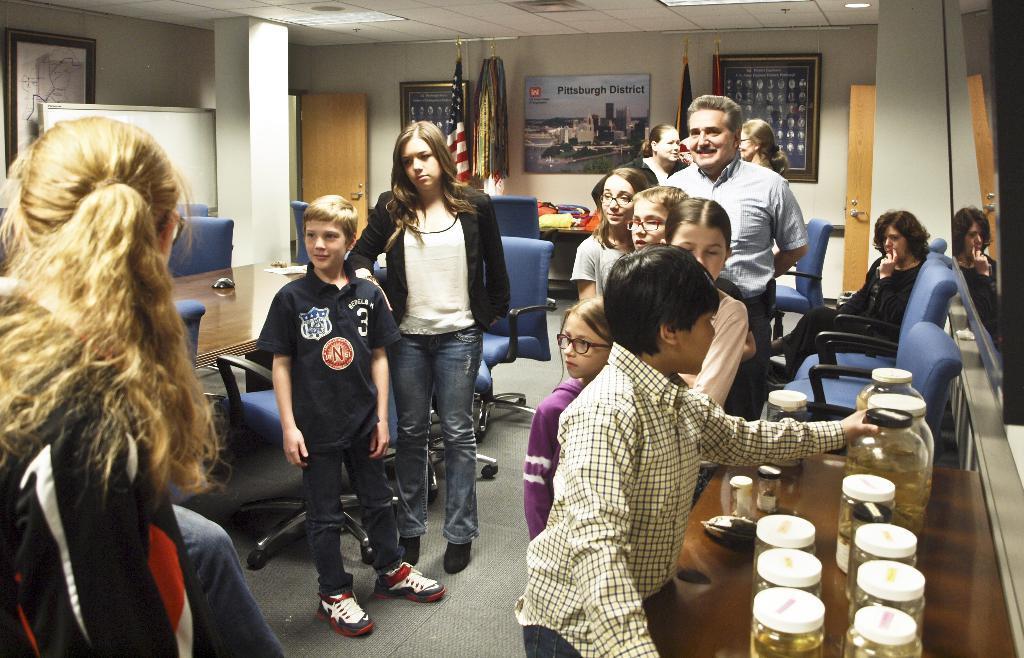How would you summarize this image in a sentence or two? In this image, we can see people and some of them are wearing glasses. In the background, there are chairs, tables and there are some jars on the stand and we can see flags and there are boards and frames on the wall and some other objects on the table. At the top, there are lights and there is a roof. At the bottom, there is a floor. 